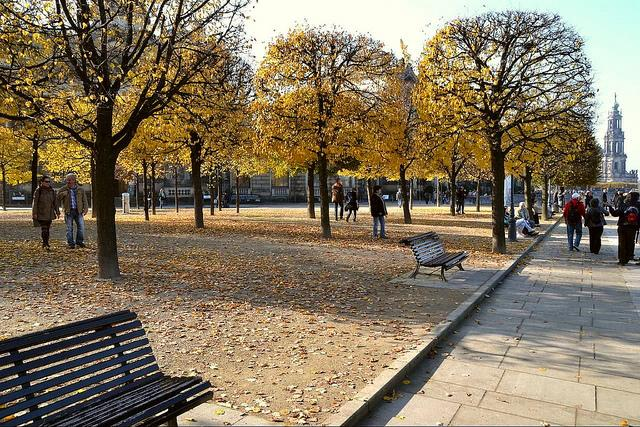How many months till the leaves turn green? Please explain your reasoning. 5-7. The leaves turn yellow/brown in the fall and turn green in the spring. from fall to spring is almost 1/2 of a year. 